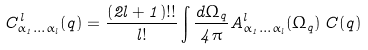Convert formula to latex. <formula><loc_0><loc_0><loc_500><loc_500>C ^ { l } _ { \alpha _ { 1 } \dots \alpha _ { l } } ( q ) = \frac { ( 2 l + 1 ) ! ! } { l ! } \int \frac { d \Omega _ { q } } { 4 \pi } A ^ { l } _ { \alpha _ { 1 } \dots \alpha _ { l } } ( \Omega _ { q } ) \, C ( q )</formula> 